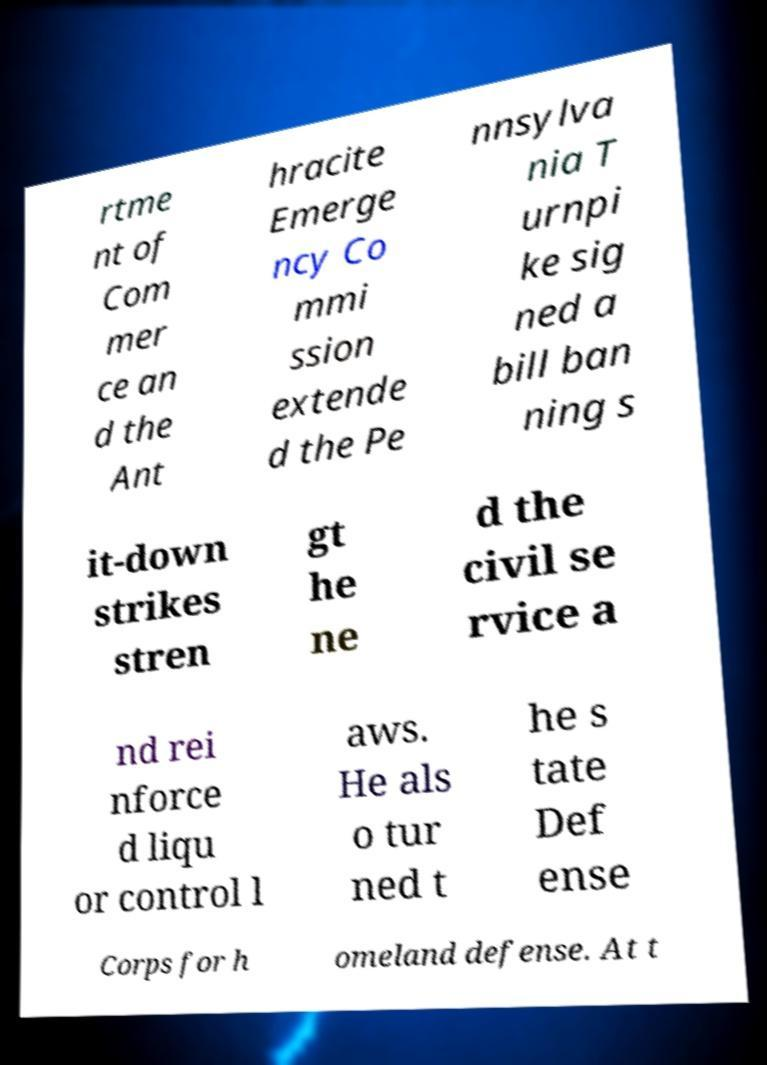Can you accurately transcribe the text from the provided image for me? rtme nt of Com mer ce an d the Ant hracite Emerge ncy Co mmi ssion extende d the Pe nnsylva nia T urnpi ke sig ned a bill ban ning s it-down strikes stren gt he ne d the civil se rvice a nd rei nforce d liqu or control l aws. He als o tur ned t he s tate Def ense Corps for h omeland defense. At t 